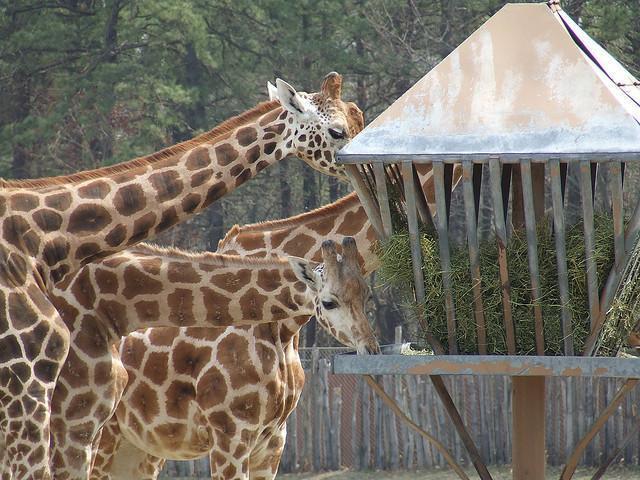How many giraffes are there?
Give a very brief answer. 3. 